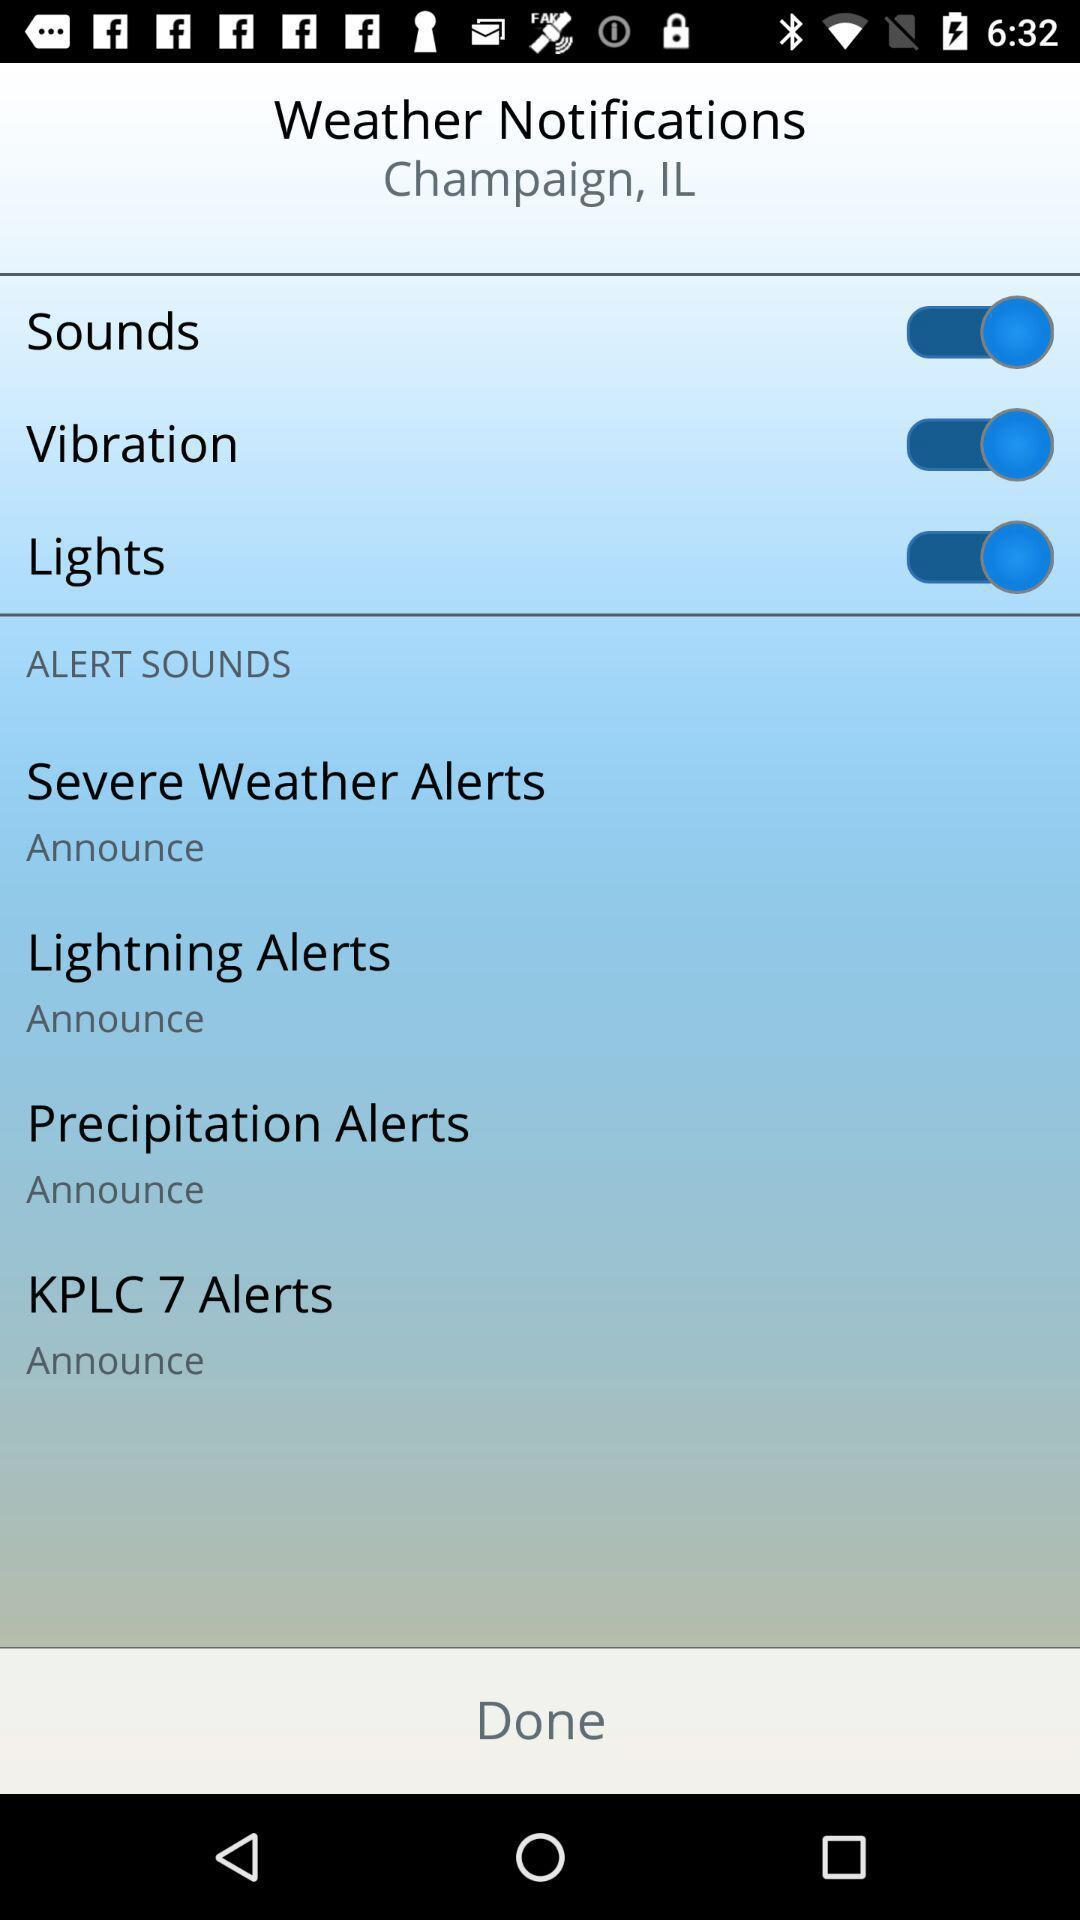What options are enabled under the "Weather Notifications"? The options that are enabled under the "Weather Notifications" are "Sounds", "Vibration", and "Lights". 